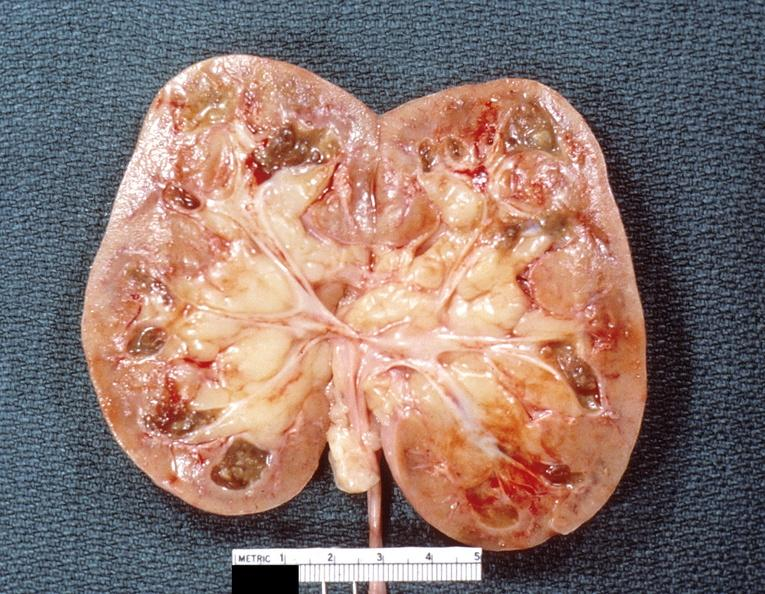where is this?
Answer the question using a single word or phrase. Urinary 